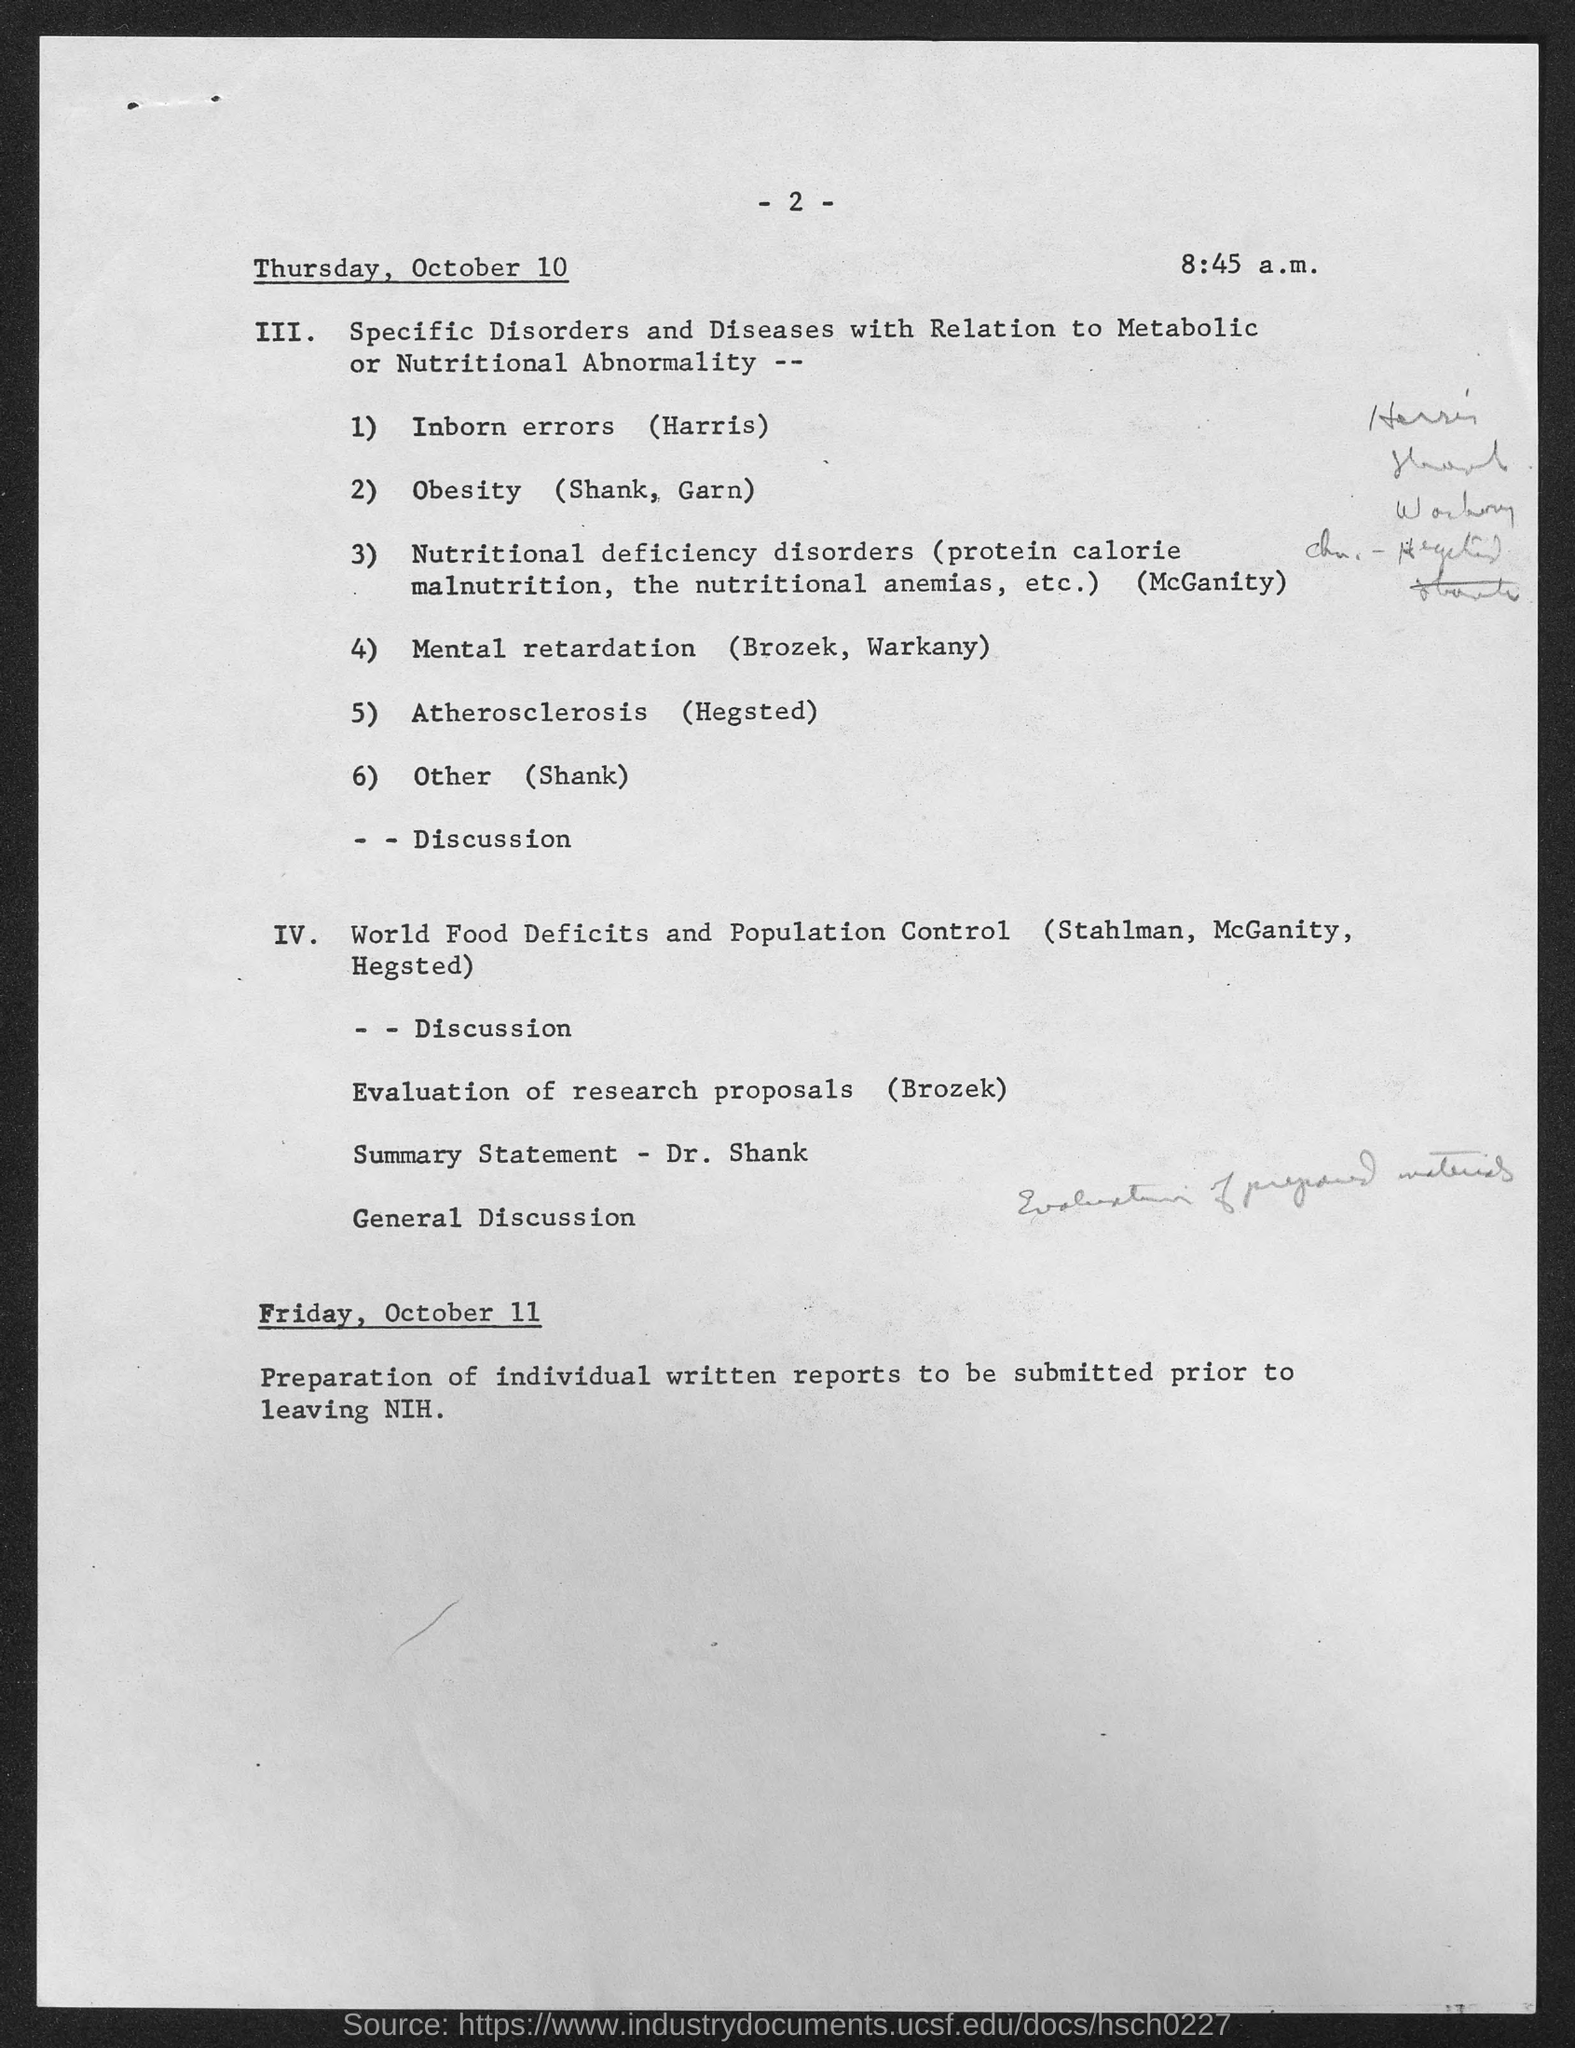What is the page no mentioned in this document?
Your answer should be compact. -2-. What is the time mentioned in this document?
Offer a terse response. 8:45 a.m. When is the preparation of individual written reports to be submitted prior to leaving NIH done?
Offer a terse response. Friday, October 11. 